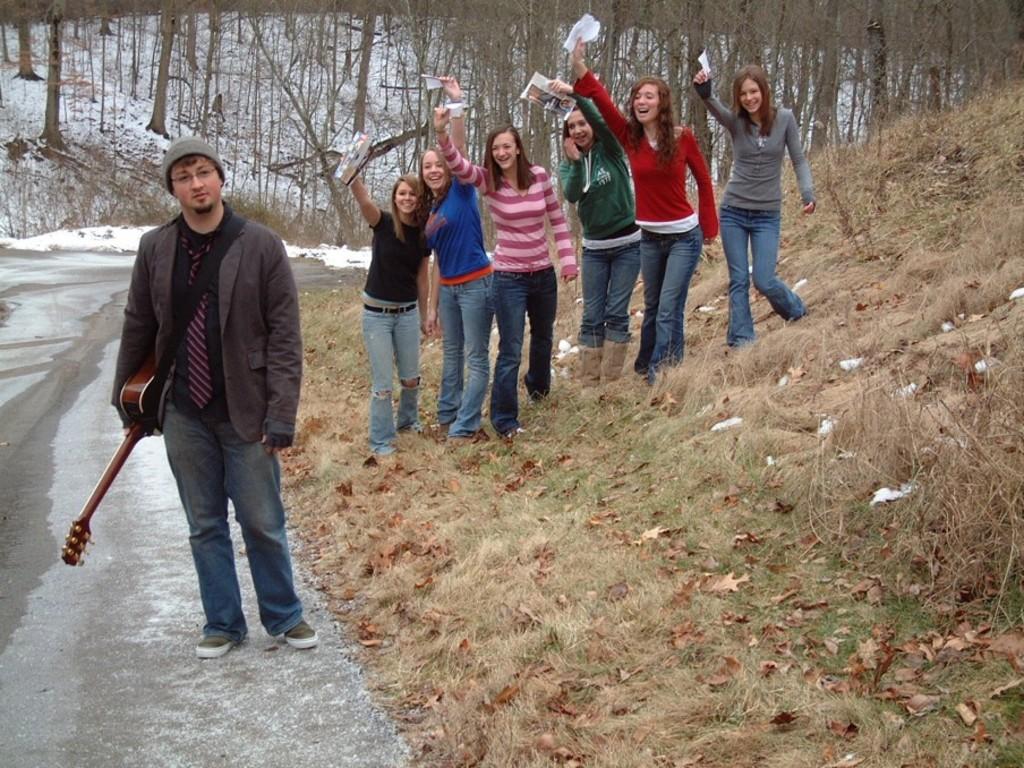Please provide a concise description of this image. In this image in the foreground there is a person holding a musical instrument standing on road, on the right side there are few women holding papers, at the top there are some trees. 